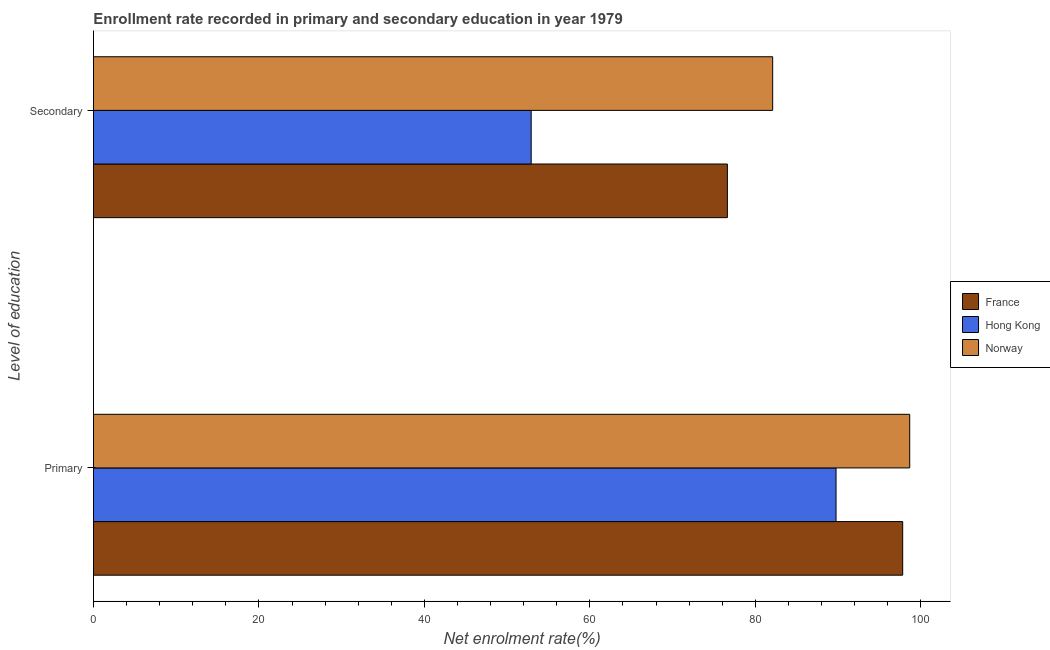How many groups of bars are there?
Provide a short and direct response. 2. How many bars are there on the 2nd tick from the bottom?
Your answer should be very brief. 3. What is the label of the 2nd group of bars from the top?
Provide a succinct answer. Primary. What is the enrollment rate in secondary education in Hong Kong?
Your response must be concise. 52.9. Across all countries, what is the maximum enrollment rate in primary education?
Offer a terse response. 98.66. Across all countries, what is the minimum enrollment rate in primary education?
Provide a succinct answer. 89.75. In which country was the enrollment rate in primary education minimum?
Provide a succinct answer. Hong Kong. What is the total enrollment rate in primary education in the graph?
Keep it short and to the point. 286.22. What is the difference between the enrollment rate in secondary education in Hong Kong and that in Norway?
Provide a short and direct response. -29.19. What is the difference between the enrollment rate in secondary education in Norway and the enrollment rate in primary education in France?
Your response must be concise. -15.72. What is the average enrollment rate in secondary education per country?
Provide a succinct answer. 70.54. What is the difference between the enrollment rate in primary education and enrollment rate in secondary education in France?
Your answer should be very brief. 21.19. What is the ratio of the enrollment rate in secondary education in Hong Kong to that in Norway?
Ensure brevity in your answer.  0.64. What does the 1st bar from the bottom in Primary represents?
Ensure brevity in your answer.  France. What is the difference between two consecutive major ticks on the X-axis?
Provide a succinct answer. 20. Are the values on the major ticks of X-axis written in scientific E-notation?
Provide a short and direct response. No. Does the graph contain any zero values?
Give a very brief answer. No. Where does the legend appear in the graph?
Provide a succinct answer. Center right. How are the legend labels stacked?
Keep it short and to the point. Vertical. What is the title of the graph?
Your answer should be compact. Enrollment rate recorded in primary and secondary education in year 1979. What is the label or title of the X-axis?
Provide a succinct answer. Net enrolment rate(%). What is the label or title of the Y-axis?
Your answer should be very brief. Level of education. What is the Net enrolment rate(%) in France in Primary?
Your answer should be compact. 97.81. What is the Net enrolment rate(%) of Hong Kong in Primary?
Provide a short and direct response. 89.75. What is the Net enrolment rate(%) of Norway in Primary?
Make the answer very short. 98.66. What is the Net enrolment rate(%) in France in Secondary?
Your answer should be very brief. 76.62. What is the Net enrolment rate(%) in Hong Kong in Secondary?
Offer a terse response. 52.9. What is the Net enrolment rate(%) in Norway in Secondary?
Offer a terse response. 82.09. Across all Level of education, what is the maximum Net enrolment rate(%) of France?
Your answer should be compact. 97.81. Across all Level of education, what is the maximum Net enrolment rate(%) of Hong Kong?
Offer a very short reply. 89.75. Across all Level of education, what is the maximum Net enrolment rate(%) of Norway?
Your answer should be compact. 98.66. Across all Level of education, what is the minimum Net enrolment rate(%) of France?
Your answer should be compact. 76.62. Across all Level of education, what is the minimum Net enrolment rate(%) in Hong Kong?
Offer a very short reply. 52.9. Across all Level of education, what is the minimum Net enrolment rate(%) of Norway?
Keep it short and to the point. 82.09. What is the total Net enrolment rate(%) of France in the graph?
Provide a succinct answer. 174.43. What is the total Net enrolment rate(%) in Hong Kong in the graph?
Offer a very short reply. 142.66. What is the total Net enrolment rate(%) of Norway in the graph?
Your response must be concise. 180.75. What is the difference between the Net enrolment rate(%) of France in Primary and that in Secondary?
Your answer should be compact. 21.19. What is the difference between the Net enrolment rate(%) in Hong Kong in Primary and that in Secondary?
Make the answer very short. 36.85. What is the difference between the Net enrolment rate(%) in Norway in Primary and that in Secondary?
Keep it short and to the point. 16.56. What is the difference between the Net enrolment rate(%) of France in Primary and the Net enrolment rate(%) of Hong Kong in Secondary?
Ensure brevity in your answer.  44.9. What is the difference between the Net enrolment rate(%) of France in Primary and the Net enrolment rate(%) of Norway in Secondary?
Your answer should be compact. 15.72. What is the difference between the Net enrolment rate(%) in Hong Kong in Primary and the Net enrolment rate(%) in Norway in Secondary?
Offer a very short reply. 7.66. What is the average Net enrolment rate(%) in France per Level of education?
Your answer should be compact. 87.21. What is the average Net enrolment rate(%) of Hong Kong per Level of education?
Make the answer very short. 71.33. What is the average Net enrolment rate(%) in Norway per Level of education?
Your answer should be compact. 90.37. What is the difference between the Net enrolment rate(%) of France and Net enrolment rate(%) of Hong Kong in Primary?
Provide a short and direct response. 8.06. What is the difference between the Net enrolment rate(%) of France and Net enrolment rate(%) of Norway in Primary?
Provide a succinct answer. -0.85. What is the difference between the Net enrolment rate(%) in Hong Kong and Net enrolment rate(%) in Norway in Primary?
Ensure brevity in your answer.  -8.9. What is the difference between the Net enrolment rate(%) in France and Net enrolment rate(%) in Hong Kong in Secondary?
Make the answer very short. 23.71. What is the difference between the Net enrolment rate(%) of France and Net enrolment rate(%) of Norway in Secondary?
Offer a very short reply. -5.48. What is the difference between the Net enrolment rate(%) of Hong Kong and Net enrolment rate(%) of Norway in Secondary?
Offer a terse response. -29.19. What is the ratio of the Net enrolment rate(%) in France in Primary to that in Secondary?
Give a very brief answer. 1.28. What is the ratio of the Net enrolment rate(%) of Hong Kong in Primary to that in Secondary?
Provide a short and direct response. 1.7. What is the ratio of the Net enrolment rate(%) of Norway in Primary to that in Secondary?
Your response must be concise. 1.2. What is the difference between the highest and the second highest Net enrolment rate(%) of France?
Offer a very short reply. 21.19. What is the difference between the highest and the second highest Net enrolment rate(%) of Hong Kong?
Make the answer very short. 36.85. What is the difference between the highest and the second highest Net enrolment rate(%) of Norway?
Give a very brief answer. 16.56. What is the difference between the highest and the lowest Net enrolment rate(%) in France?
Your answer should be very brief. 21.19. What is the difference between the highest and the lowest Net enrolment rate(%) in Hong Kong?
Provide a succinct answer. 36.85. What is the difference between the highest and the lowest Net enrolment rate(%) in Norway?
Your response must be concise. 16.56. 